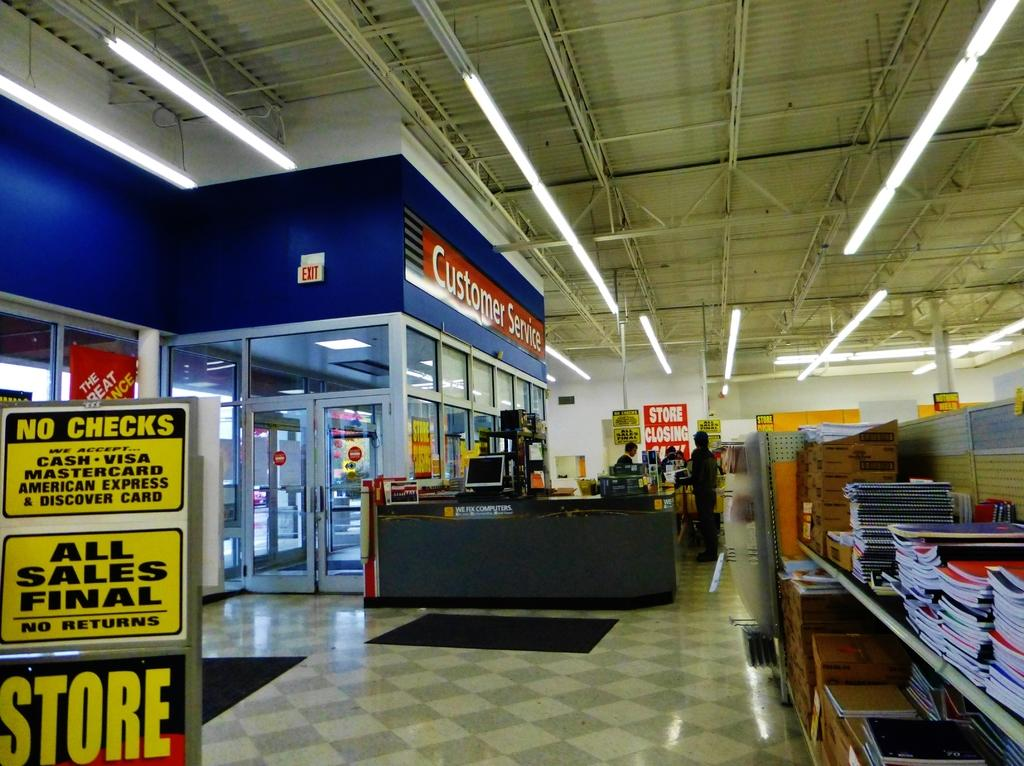<image>
Create a compact narrative representing the image presented. a store interior with departments for Customer Service 